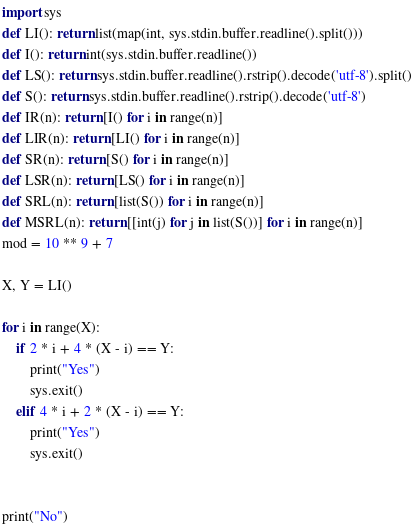Convert code to text. <code><loc_0><loc_0><loc_500><loc_500><_Python_>import sys
def LI(): return list(map(int, sys.stdin.buffer.readline().split()))
def I(): return int(sys.stdin.buffer.readline())
def LS(): return sys.stdin.buffer.readline().rstrip().decode('utf-8').split()
def S(): return sys.stdin.buffer.readline().rstrip().decode('utf-8')
def IR(n): return [I() for i in range(n)]
def LIR(n): return [LI() for i in range(n)]
def SR(n): return [S() for i in range(n)]
def LSR(n): return [LS() for i in range(n)]
def SRL(n): return [list(S()) for i in range(n)]
def MSRL(n): return [[int(j) for j in list(S())] for i in range(n)]
mod = 10 ** 9 + 7

X, Y = LI()

for i in range(X):
    if 2 * i + 4 * (X - i) == Y:
        print("Yes")
        sys.exit()
    elif 4 * i + 2 * (X - i) == Y:
        print("Yes")
        sys.exit()


print("No")   </code> 